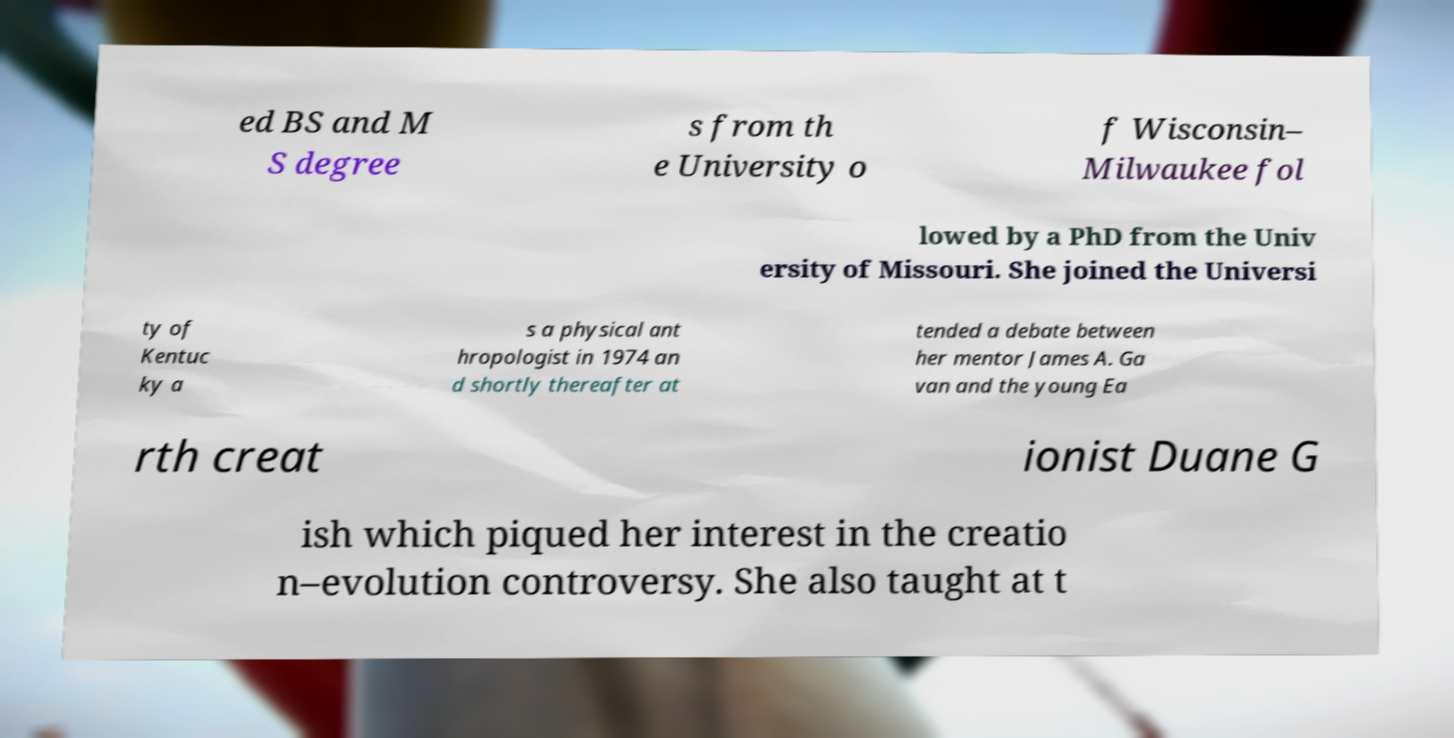Could you extract and type out the text from this image? ed BS and M S degree s from th e University o f Wisconsin– Milwaukee fol lowed by a PhD from the Univ ersity of Missouri. She joined the Universi ty of Kentuc ky a s a physical ant hropologist in 1974 an d shortly thereafter at tended a debate between her mentor James A. Ga van and the young Ea rth creat ionist Duane G ish which piqued her interest in the creatio n–evolution controversy. She also taught at t 